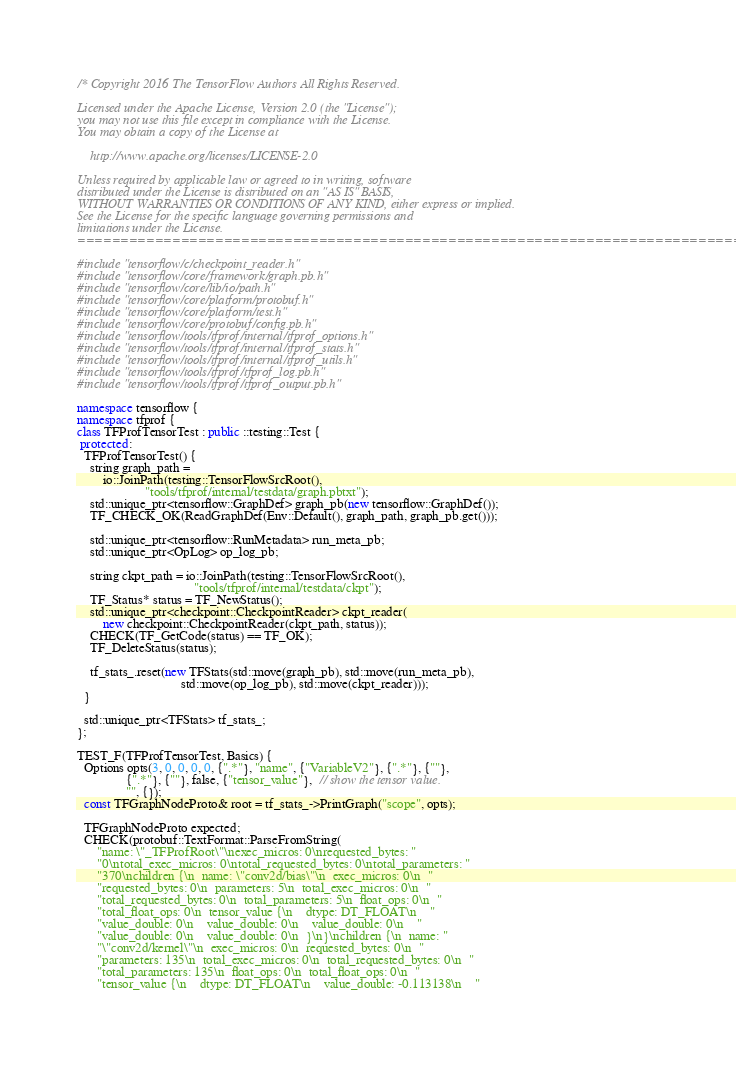Convert code to text. <code><loc_0><loc_0><loc_500><loc_500><_C++_>/* Copyright 2016 The TensorFlow Authors All Rights Reserved.

Licensed under the Apache License, Version 2.0 (the "License");
you may not use this file except in compliance with the License.
You may obtain a copy of the License at

    http://www.apache.org/licenses/LICENSE-2.0

Unless required by applicable law or agreed to in writing, software
distributed under the License is distributed on an "AS IS" BASIS,
WITHOUT WARRANTIES OR CONDITIONS OF ANY KIND, either express or implied.
See the License for the specific language governing permissions and
limitations under the License.
==============================================================================*/

#include "tensorflow/c/checkpoint_reader.h"
#include "tensorflow/core/framework/graph.pb.h"
#include "tensorflow/core/lib/io/path.h"
#include "tensorflow/core/platform/protobuf.h"
#include "tensorflow/core/platform/test.h"
#include "tensorflow/core/protobuf/config.pb.h"
#include "tensorflow/tools/tfprof/internal/tfprof_options.h"
#include "tensorflow/tools/tfprof/internal/tfprof_stats.h"
#include "tensorflow/tools/tfprof/internal/tfprof_utils.h"
#include "tensorflow/tools/tfprof/tfprof_log.pb.h"
#include "tensorflow/tools/tfprof/tfprof_output.pb.h"

namespace tensorflow {
namespace tfprof {
class TFProfTensorTest : public ::testing::Test {
 protected:
  TFProfTensorTest() {
    string graph_path =
        io::JoinPath(testing::TensorFlowSrcRoot(),
                     "tools/tfprof/internal/testdata/graph.pbtxt");
    std::unique_ptr<tensorflow::GraphDef> graph_pb(new tensorflow::GraphDef());
    TF_CHECK_OK(ReadGraphDef(Env::Default(), graph_path, graph_pb.get()));

    std::unique_ptr<tensorflow::RunMetadata> run_meta_pb;
    std::unique_ptr<OpLog> op_log_pb;

    string ckpt_path = io::JoinPath(testing::TensorFlowSrcRoot(),
                                    "tools/tfprof/internal/testdata/ckpt");
    TF_Status* status = TF_NewStatus();
    std::unique_ptr<checkpoint::CheckpointReader> ckpt_reader(
        new checkpoint::CheckpointReader(ckpt_path, status));
    CHECK(TF_GetCode(status) == TF_OK);
    TF_DeleteStatus(status);

    tf_stats_.reset(new TFStats(std::move(graph_pb), std::move(run_meta_pb),
                                std::move(op_log_pb), std::move(ckpt_reader)));
  }

  std::unique_ptr<TFStats> tf_stats_;
};

TEST_F(TFProfTensorTest, Basics) {
  Options opts(3, 0, 0, 0, 0, {".*"}, "name", {"VariableV2"}, {".*"}, {""},
               {".*"}, {""}, false, {"tensor_value"},  // show the tensor value.
               "", {});
  const TFGraphNodeProto& root = tf_stats_->PrintGraph("scope", opts);

  TFGraphNodeProto expected;
  CHECK(protobuf::TextFormat::ParseFromString(
      "name: \"_TFProfRoot\"\nexec_micros: 0\nrequested_bytes: "
      "0\ntotal_exec_micros: 0\ntotal_requested_bytes: 0\ntotal_parameters: "
      "370\nchildren {\n  name: \"conv2d/bias\"\n  exec_micros: 0\n  "
      "requested_bytes: 0\n  parameters: 5\n  total_exec_micros: 0\n  "
      "total_requested_bytes: 0\n  total_parameters: 5\n  float_ops: 0\n  "
      "total_float_ops: 0\n  tensor_value {\n    dtype: DT_FLOAT\n    "
      "value_double: 0\n    value_double: 0\n    value_double: 0\n    "
      "value_double: 0\n    value_double: 0\n  }\n}\nchildren {\n  name: "
      "\"conv2d/kernel\"\n  exec_micros: 0\n  requested_bytes: 0\n  "
      "parameters: 135\n  total_exec_micros: 0\n  total_requested_bytes: 0\n  "
      "total_parameters: 135\n  float_ops: 0\n  total_float_ops: 0\n  "
      "tensor_value {\n    dtype: DT_FLOAT\n    value_double: -0.113138\n    "</code> 